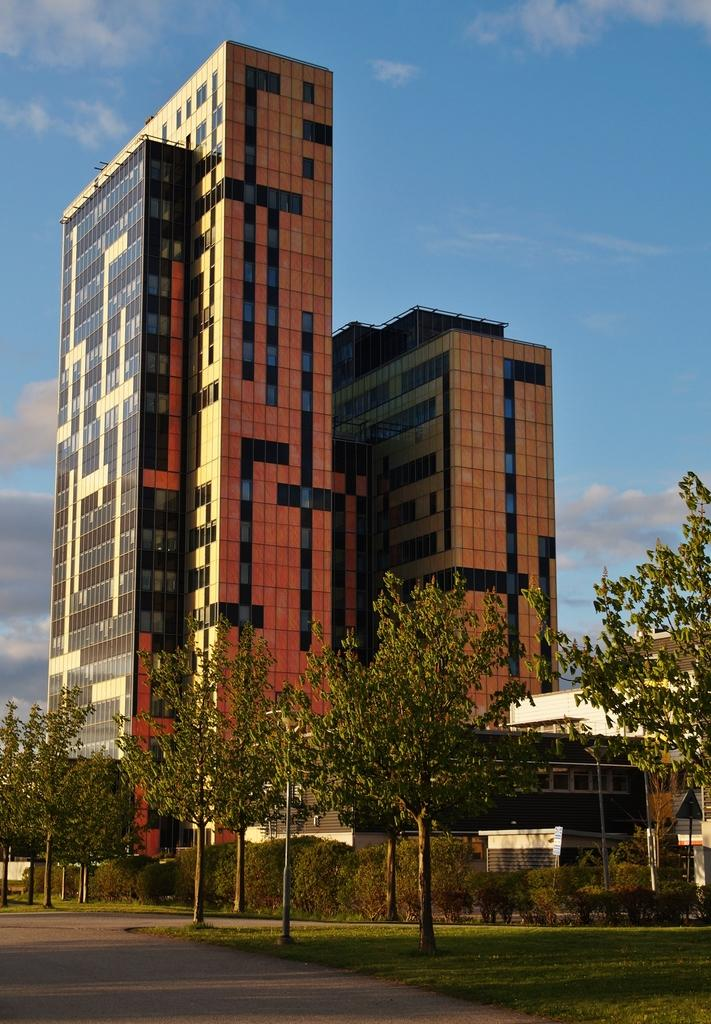What type of structures can be seen in the image? There are buildings in the image. What is located in front of the buildings? There is a wall, plants, trees, and grass in front of the buildings. What can be seen behind the buildings? The sky is visible behind the buildings. What type of verse is being recited in front of the buildings? There is no indication in the image that a verse is being recited; the focus is on the buildings, wall, plants, trees, grass, and sky. 